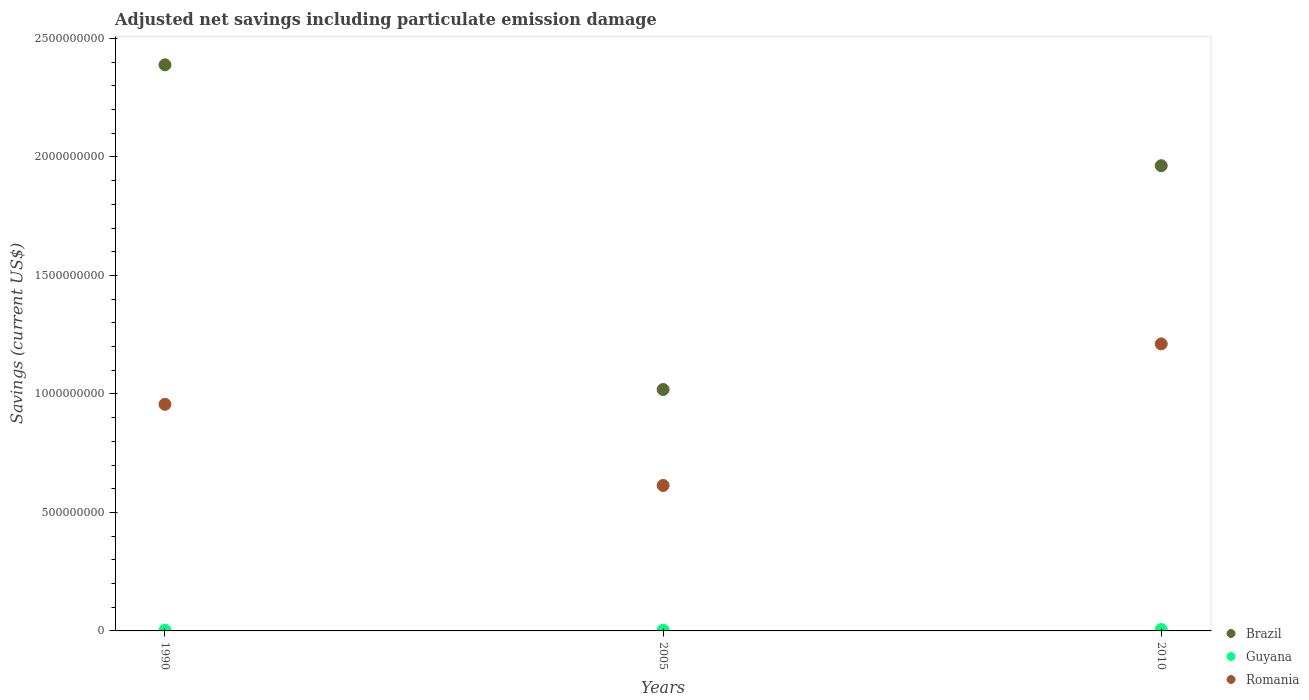How many different coloured dotlines are there?
Give a very brief answer. 3. Is the number of dotlines equal to the number of legend labels?
Your answer should be compact. Yes. What is the net savings in Romania in 2010?
Your answer should be very brief. 1.21e+09. Across all years, what is the maximum net savings in Romania?
Provide a short and direct response. 1.21e+09. Across all years, what is the minimum net savings in Romania?
Keep it short and to the point. 6.14e+08. What is the total net savings in Romania in the graph?
Provide a succinct answer. 2.78e+09. What is the difference between the net savings in Brazil in 1990 and that in 2010?
Keep it short and to the point. 4.26e+08. What is the difference between the net savings in Romania in 2005 and the net savings in Brazil in 2010?
Your answer should be very brief. -1.35e+09. What is the average net savings in Brazil per year?
Provide a succinct answer. 1.79e+09. In the year 2010, what is the difference between the net savings in Guyana and net savings in Brazil?
Provide a short and direct response. -1.96e+09. What is the ratio of the net savings in Romania in 1990 to that in 2010?
Your answer should be compact. 0.79. What is the difference between the highest and the second highest net savings in Brazil?
Offer a terse response. 4.26e+08. What is the difference between the highest and the lowest net savings in Guyana?
Offer a very short reply. 3.17e+06. In how many years, is the net savings in Guyana greater than the average net savings in Guyana taken over all years?
Ensure brevity in your answer.  1. Is the sum of the net savings in Romania in 1990 and 2010 greater than the maximum net savings in Guyana across all years?
Offer a terse response. Yes. Does the net savings in Brazil monotonically increase over the years?
Give a very brief answer. No. Is the net savings in Guyana strictly less than the net savings in Romania over the years?
Your response must be concise. Yes. How many dotlines are there?
Make the answer very short. 3. Are the values on the major ticks of Y-axis written in scientific E-notation?
Provide a short and direct response. No. Does the graph contain any zero values?
Your answer should be very brief. No. Where does the legend appear in the graph?
Your answer should be very brief. Bottom right. How many legend labels are there?
Provide a short and direct response. 3. How are the legend labels stacked?
Ensure brevity in your answer.  Vertical. What is the title of the graph?
Keep it short and to the point. Adjusted net savings including particulate emission damage. What is the label or title of the X-axis?
Provide a succinct answer. Years. What is the label or title of the Y-axis?
Offer a very short reply. Savings (current US$). What is the Savings (current US$) in Brazil in 1990?
Provide a succinct answer. 2.39e+09. What is the Savings (current US$) of Guyana in 1990?
Provide a short and direct response. 3.37e+06. What is the Savings (current US$) of Romania in 1990?
Offer a very short reply. 9.56e+08. What is the Savings (current US$) in Brazil in 2005?
Provide a succinct answer. 1.02e+09. What is the Savings (current US$) of Guyana in 2005?
Ensure brevity in your answer.  2.82e+06. What is the Savings (current US$) of Romania in 2005?
Ensure brevity in your answer.  6.14e+08. What is the Savings (current US$) of Brazil in 2010?
Give a very brief answer. 1.96e+09. What is the Savings (current US$) in Guyana in 2010?
Offer a very short reply. 6.00e+06. What is the Savings (current US$) in Romania in 2010?
Ensure brevity in your answer.  1.21e+09. Across all years, what is the maximum Savings (current US$) in Brazil?
Give a very brief answer. 2.39e+09. Across all years, what is the maximum Savings (current US$) in Guyana?
Your response must be concise. 6.00e+06. Across all years, what is the maximum Savings (current US$) in Romania?
Ensure brevity in your answer.  1.21e+09. Across all years, what is the minimum Savings (current US$) in Brazil?
Provide a short and direct response. 1.02e+09. Across all years, what is the minimum Savings (current US$) of Guyana?
Provide a succinct answer. 2.82e+06. Across all years, what is the minimum Savings (current US$) of Romania?
Make the answer very short. 6.14e+08. What is the total Savings (current US$) of Brazil in the graph?
Provide a succinct answer. 5.37e+09. What is the total Savings (current US$) in Guyana in the graph?
Give a very brief answer. 1.22e+07. What is the total Savings (current US$) of Romania in the graph?
Keep it short and to the point. 2.78e+09. What is the difference between the Savings (current US$) of Brazil in 1990 and that in 2005?
Provide a short and direct response. 1.37e+09. What is the difference between the Savings (current US$) in Guyana in 1990 and that in 2005?
Offer a very short reply. 5.50e+05. What is the difference between the Savings (current US$) in Romania in 1990 and that in 2005?
Your answer should be compact. 3.42e+08. What is the difference between the Savings (current US$) of Brazil in 1990 and that in 2010?
Your answer should be very brief. 4.26e+08. What is the difference between the Savings (current US$) in Guyana in 1990 and that in 2010?
Ensure brevity in your answer.  -2.62e+06. What is the difference between the Savings (current US$) of Romania in 1990 and that in 2010?
Your answer should be compact. -2.55e+08. What is the difference between the Savings (current US$) of Brazil in 2005 and that in 2010?
Your response must be concise. -9.44e+08. What is the difference between the Savings (current US$) of Guyana in 2005 and that in 2010?
Make the answer very short. -3.17e+06. What is the difference between the Savings (current US$) in Romania in 2005 and that in 2010?
Keep it short and to the point. -5.97e+08. What is the difference between the Savings (current US$) in Brazil in 1990 and the Savings (current US$) in Guyana in 2005?
Offer a very short reply. 2.39e+09. What is the difference between the Savings (current US$) of Brazil in 1990 and the Savings (current US$) of Romania in 2005?
Give a very brief answer. 1.77e+09. What is the difference between the Savings (current US$) of Guyana in 1990 and the Savings (current US$) of Romania in 2005?
Keep it short and to the point. -6.10e+08. What is the difference between the Savings (current US$) of Brazil in 1990 and the Savings (current US$) of Guyana in 2010?
Make the answer very short. 2.38e+09. What is the difference between the Savings (current US$) in Brazil in 1990 and the Savings (current US$) in Romania in 2010?
Offer a terse response. 1.18e+09. What is the difference between the Savings (current US$) of Guyana in 1990 and the Savings (current US$) of Romania in 2010?
Offer a terse response. -1.21e+09. What is the difference between the Savings (current US$) of Brazil in 2005 and the Savings (current US$) of Guyana in 2010?
Offer a terse response. 1.01e+09. What is the difference between the Savings (current US$) of Brazil in 2005 and the Savings (current US$) of Romania in 2010?
Your answer should be very brief. -1.92e+08. What is the difference between the Savings (current US$) of Guyana in 2005 and the Savings (current US$) of Romania in 2010?
Offer a terse response. -1.21e+09. What is the average Savings (current US$) of Brazil per year?
Offer a terse response. 1.79e+09. What is the average Savings (current US$) in Guyana per year?
Your response must be concise. 4.07e+06. What is the average Savings (current US$) in Romania per year?
Make the answer very short. 9.27e+08. In the year 1990, what is the difference between the Savings (current US$) in Brazil and Savings (current US$) in Guyana?
Provide a succinct answer. 2.39e+09. In the year 1990, what is the difference between the Savings (current US$) in Brazil and Savings (current US$) in Romania?
Ensure brevity in your answer.  1.43e+09. In the year 1990, what is the difference between the Savings (current US$) in Guyana and Savings (current US$) in Romania?
Ensure brevity in your answer.  -9.53e+08. In the year 2005, what is the difference between the Savings (current US$) in Brazil and Savings (current US$) in Guyana?
Offer a very short reply. 1.02e+09. In the year 2005, what is the difference between the Savings (current US$) of Brazil and Savings (current US$) of Romania?
Make the answer very short. 4.05e+08. In the year 2005, what is the difference between the Savings (current US$) in Guyana and Savings (current US$) in Romania?
Give a very brief answer. -6.11e+08. In the year 2010, what is the difference between the Savings (current US$) of Brazil and Savings (current US$) of Guyana?
Offer a very short reply. 1.96e+09. In the year 2010, what is the difference between the Savings (current US$) of Brazil and Savings (current US$) of Romania?
Ensure brevity in your answer.  7.52e+08. In the year 2010, what is the difference between the Savings (current US$) of Guyana and Savings (current US$) of Romania?
Offer a terse response. -1.21e+09. What is the ratio of the Savings (current US$) in Brazil in 1990 to that in 2005?
Offer a very short reply. 2.34. What is the ratio of the Savings (current US$) in Guyana in 1990 to that in 2005?
Your response must be concise. 1.19. What is the ratio of the Savings (current US$) of Romania in 1990 to that in 2005?
Your response must be concise. 1.56. What is the ratio of the Savings (current US$) of Brazil in 1990 to that in 2010?
Your answer should be compact. 1.22. What is the ratio of the Savings (current US$) of Guyana in 1990 to that in 2010?
Offer a terse response. 0.56. What is the ratio of the Savings (current US$) in Romania in 1990 to that in 2010?
Offer a very short reply. 0.79. What is the ratio of the Savings (current US$) of Brazil in 2005 to that in 2010?
Provide a short and direct response. 0.52. What is the ratio of the Savings (current US$) of Guyana in 2005 to that in 2010?
Offer a terse response. 0.47. What is the ratio of the Savings (current US$) in Romania in 2005 to that in 2010?
Offer a very short reply. 0.51. What is the difference between the highest and the second highest Savings (current US$) in Brazil?
Offer a very short reply. 4.26e+08. What is the difference between the highest and the second highest Savings (current US$) of Guyana?
Your response must be concise. 2.62e+06. What is the difference between the highest and the second highest Savings (current US$) in Romania?
Your answer should be compact. 2.55e+08. What is the difference between the highest and the lowest Savings (current US$) of Brazil?
Provide a short and direct response. 1.37e+09. What is the difference between the highest and the lowest Savings (current US$) of Guyana?
Ensure brevity in your answer.  3.17e+06. What is the difference between the highest and the lowest Savings (current US$) of Romania?
Keep it short and to the point. 5.97e+08. 